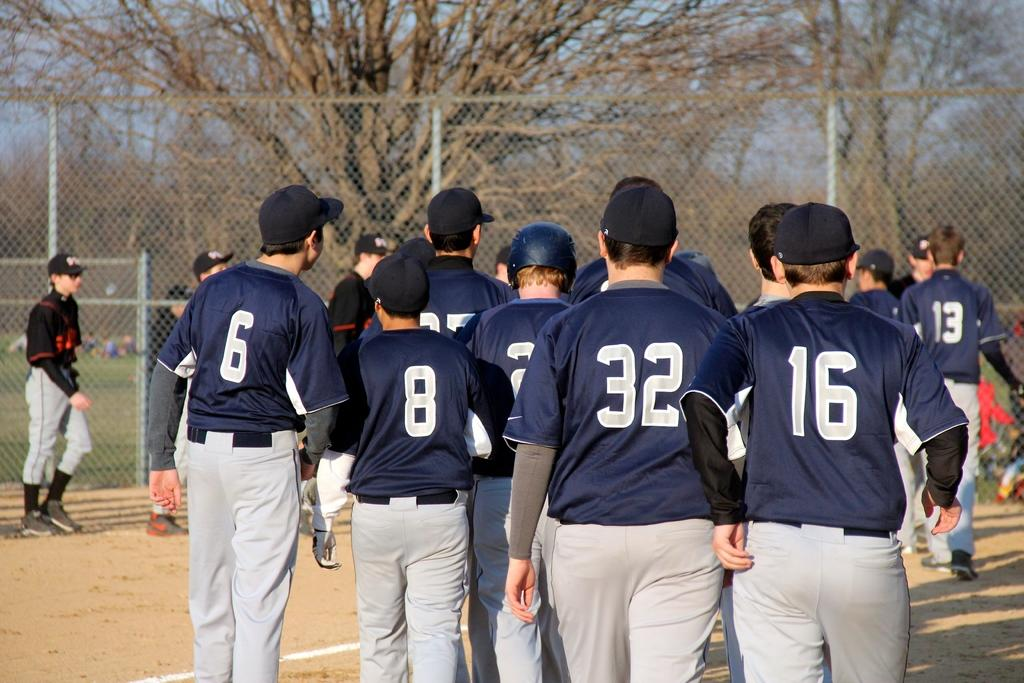<image>
Present a compact description of the photo's key features. some players with one wearing the number 32 